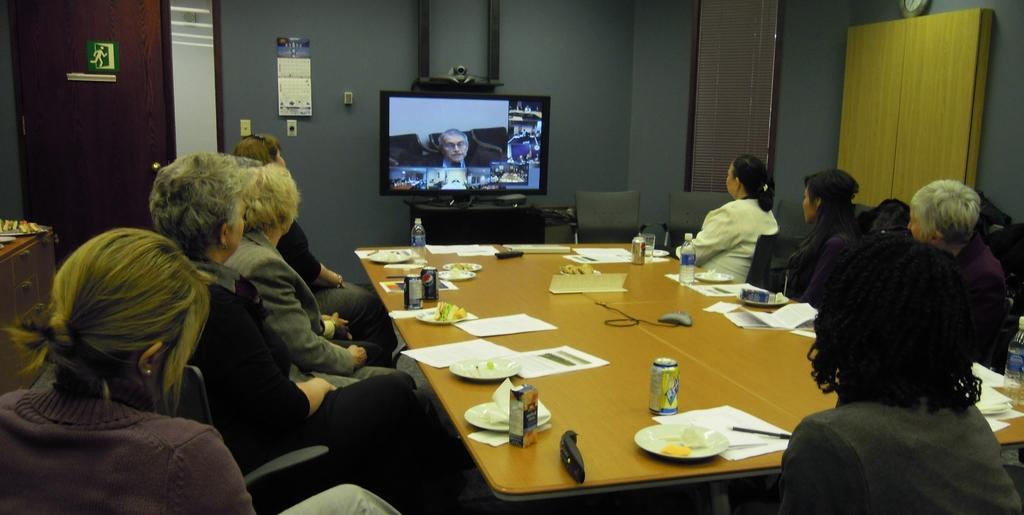Describe this image in one or two sentences. In this image I can see few people are sitting on chairs. Here on this table I can see few papers, cans, few plates and few papers. In the background I can see a television. 